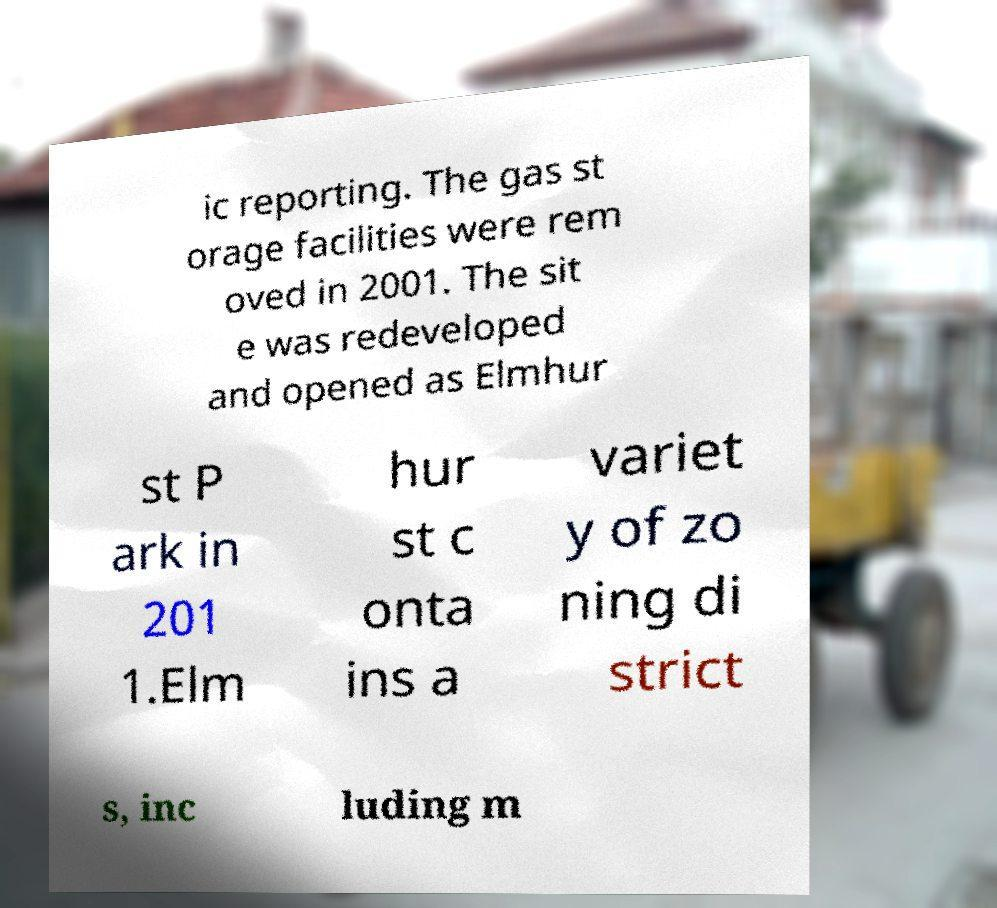What messages or text are displayed in this image? I need them in a readable, typed format. ic reporting. The gas st orage facilities were rem oved in 2001. The sit e was redeveloped and opened as Elmhur st P ark in 201 1.Elm hur st c onta ins a variet y of zo ning di strict s, inc luding m 